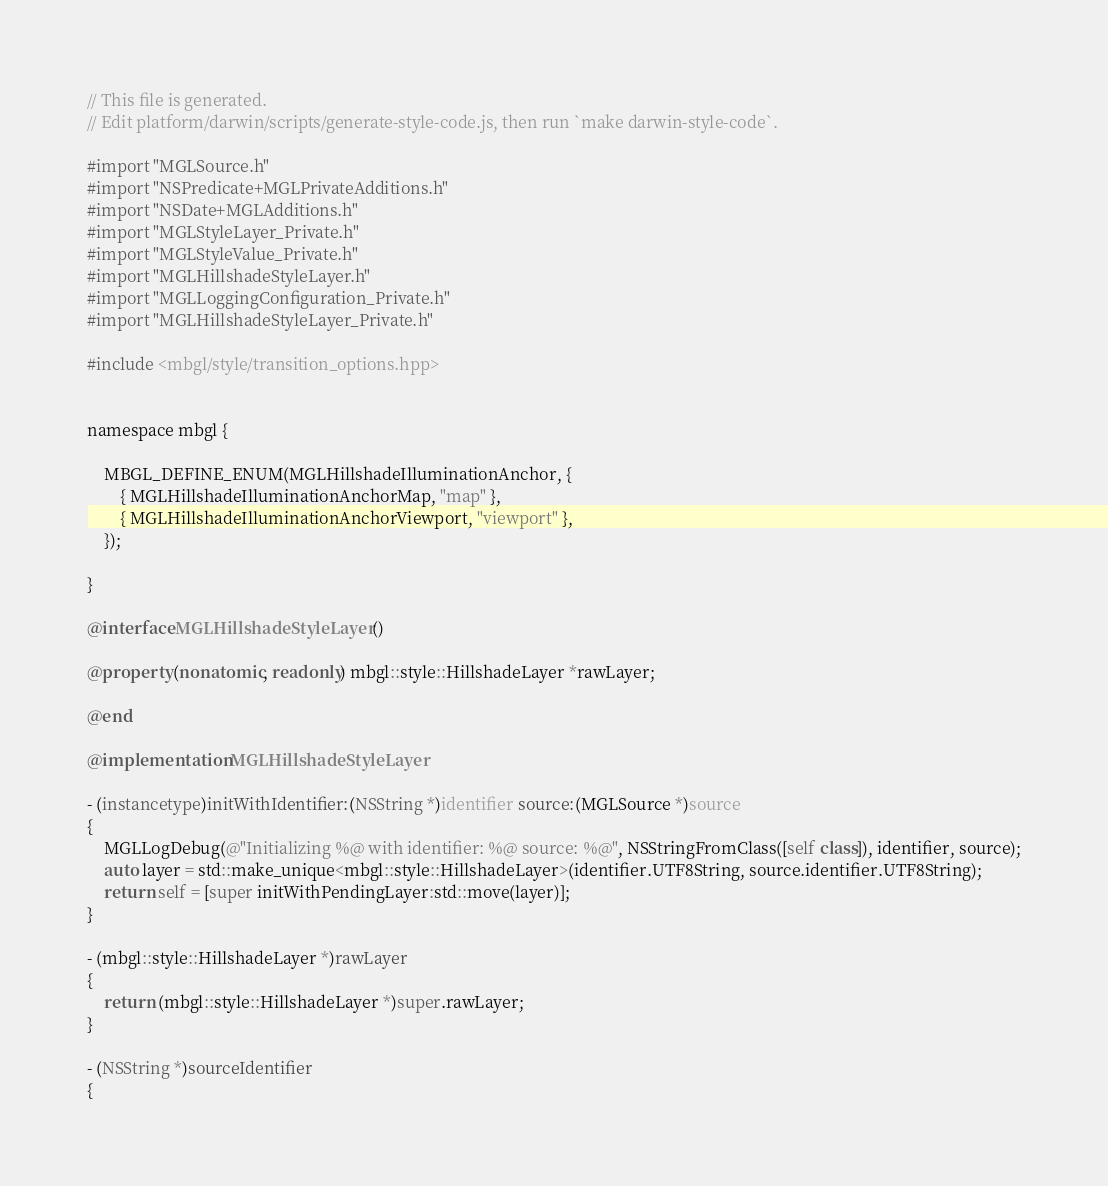Convert code to text. <code><loc_0><loc_0><loc_500><loc_500><_ObjectiveC_>// This file is generated.
// Edit platform/darwin/scripts/generate-style-code.js, then run `make darwin-style-code`.

#import "MGLSource.h"
#import "NSPredicate+MGLPrivateAdditions.h"
#import "NSDate+MGLAdditions.h"
#import "MGLStyleLayer_Private.h"
#import "MGLStyleValue_Private.h"
#import "MGLHillshadeStyleLayer.h"
#import "MGLLoggingConfiguration_Private.h"
#import "MGLHillshadeStyleLayer_Private.h"

#include <mbgl/style/transition_options.hpp>


namespace mbgl {

    MBGL_DEFINE_ENUM(MGLHillshadeIlluminationAnchor, {
        { MGLHillshadeIlluminationAnchorMap, "map" },
        { MGLHillshadeIlluminationAnchorViewport, "viewport" },
    });

}

@interface MGLHillshadeStyleLayer ()

@property (nonatomic, readonly) mbgl::style::HillshadeLayer *rawLayer;

@end

@implementation MGLHillshadeStyleLayer

- (instancetype)initWithIdentifier:(NSString *)identifier source:(MGLSource *)source
{
    MGLLogDebug(@"Initializing %@ with identifier: %@ source: %@", NSStringFromClass([self class]), identifier, source);
    auto layer = std::make_unique<mbgl::style::HillshadeLayer>(identifier.UTF8String, source.identifier.UTF8String);
    return self = [super initWithPendingLayer:std::move(layer)];
}

- (mbgl::style::HillshadeLayer *)rawLayer
{
    return (mbgl::style::HillshadeLayer *)super.rawLayer;
}

- (NSString *)sourceIdentifier
{</code> 